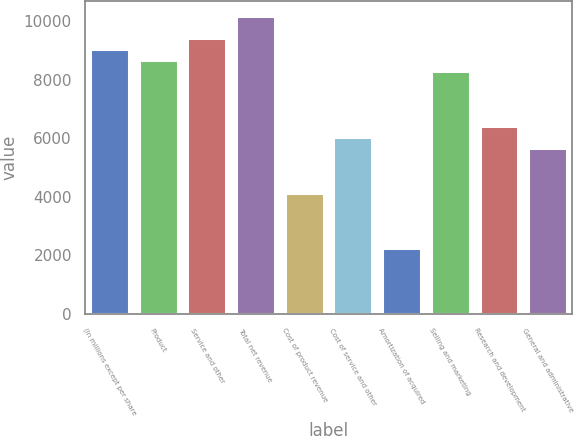Convert chart to OTSL. <chart><loc_0><loc_0><loc_500><loc_500><bar_chart><fcel>(In millions except per share<fcel>Product<fcel>Service and other<fcel>Total net revenue<fcel>Cost of product revenue<fcel>Cost of service and other<fcel>Amortization of acquired<fcel>Selling and marketing<fcel>Research and development<fcel>General and administrative<nl><fcel>9052.62<fcel>8675.43<fcel>9429.81<fcel>10184.2<fcel>4149.15<fcel>6035.1<fcel>2263.2<fcel>8298.24<fcel>6412.29<fcel>5657.91<nl></chart> 